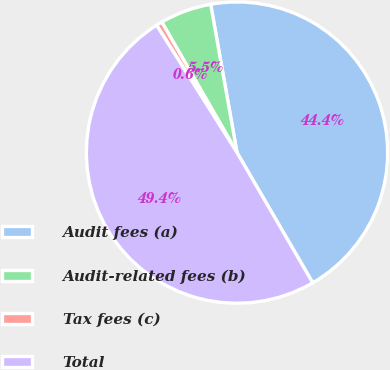Convert chart to OTSL. <chart><loc_0><loc_0><loc_500><loc_500><pie_chart><fcel>Audit fees (a)<fcel>Audit-related fees (b)<fcel>Tax fees (c)<fcel>Total<nl><fcel>44.42%<fcel>5.52%<fcel>0.64%<fcel>49.42%<nl></chart> 